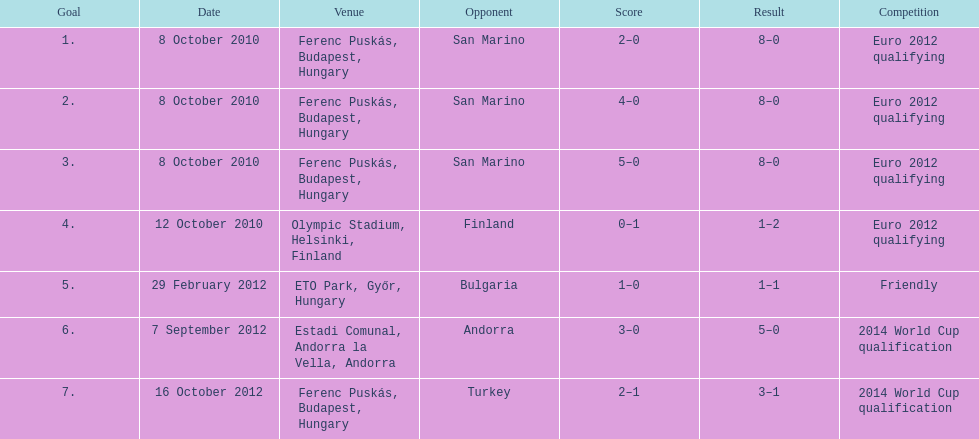Can you parse all the data within this table? {'header': ['Goal', 'Date', 'Venue', 'Opponent', 'Score', 'Result', 'Competition'], 'rows': [['1.', '8 October 2010', 'Ferenc Puskás, Budapest, Hungary', 'San Marino', '2–0', '8–0', 'Euro 2012 qualifying'], ['2.', '8 October 2010', 'Ferenc Puskás, Budapest, Hungary', 'San Marino', '4–0', '8–0', 'Euro 2012 qualifying'], ['3.', '8 October 2010', 'Ferenc Puskás, Budapest, Hungary', 'San Marino', '5–0', '8–0', 'Euro 2012 qualifying'], ['4.', '12 October 2010', 'Olympic Stadium, Helsinki, Finland', 'Finland', '0–1', '1–2', 'Euro 2012 qualifying'], ['5.', '29 February 2012', 'ETO Park, Győr, Hungary', 'Bulgaria', '1–0', '1–1', 'Friendly'], ['6.', '7 September 2012', 'Estadi Comunal, Andorra la Vella, Andorra', 'Andorra', '3–0', '5–0', '2014 World Cup qualification'], ['7.', '16 October 2012', 'Ferenc Puskás, Budapest, Hungary', 'Turkey', '2–1', '3–1', '2014 World Cup qualification']]} In how many games that were not qualifying matches did he score? 1. 